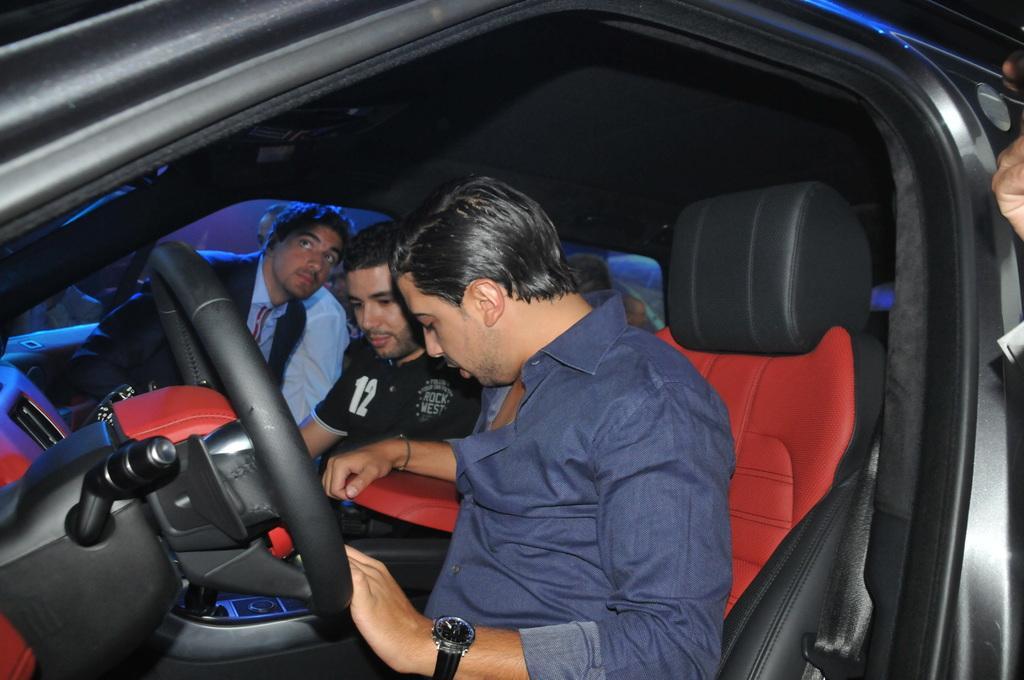Please provide a concise description of this image. In the picture we can see three people sitting in a car near the steering and we can see a red seats with black cover, a man who is sitting first is wearing a blue shirt with wrist watch which is black in color, and second person is wearing a black T-shirt and the third person is wearing a blazer, tie and shirt. 